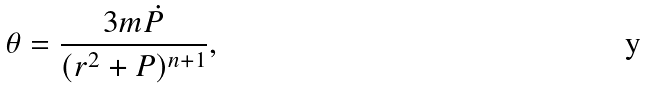Convert formula to latex. <formula><loc_0><loc_0><loc_500><loc_500>\theta = \frac { 3 m \dot { P } } { ( r ^ { 2 } + P ) ^ { n + 1 } } ,</formula> 